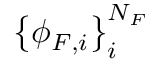Convert formula to latex. <formula><loc_0><loc_0><loc_500><loc_500>\left \{ \phi _ { F , i } \right \} _ { i } ^ { N _ { F } }</formula> 